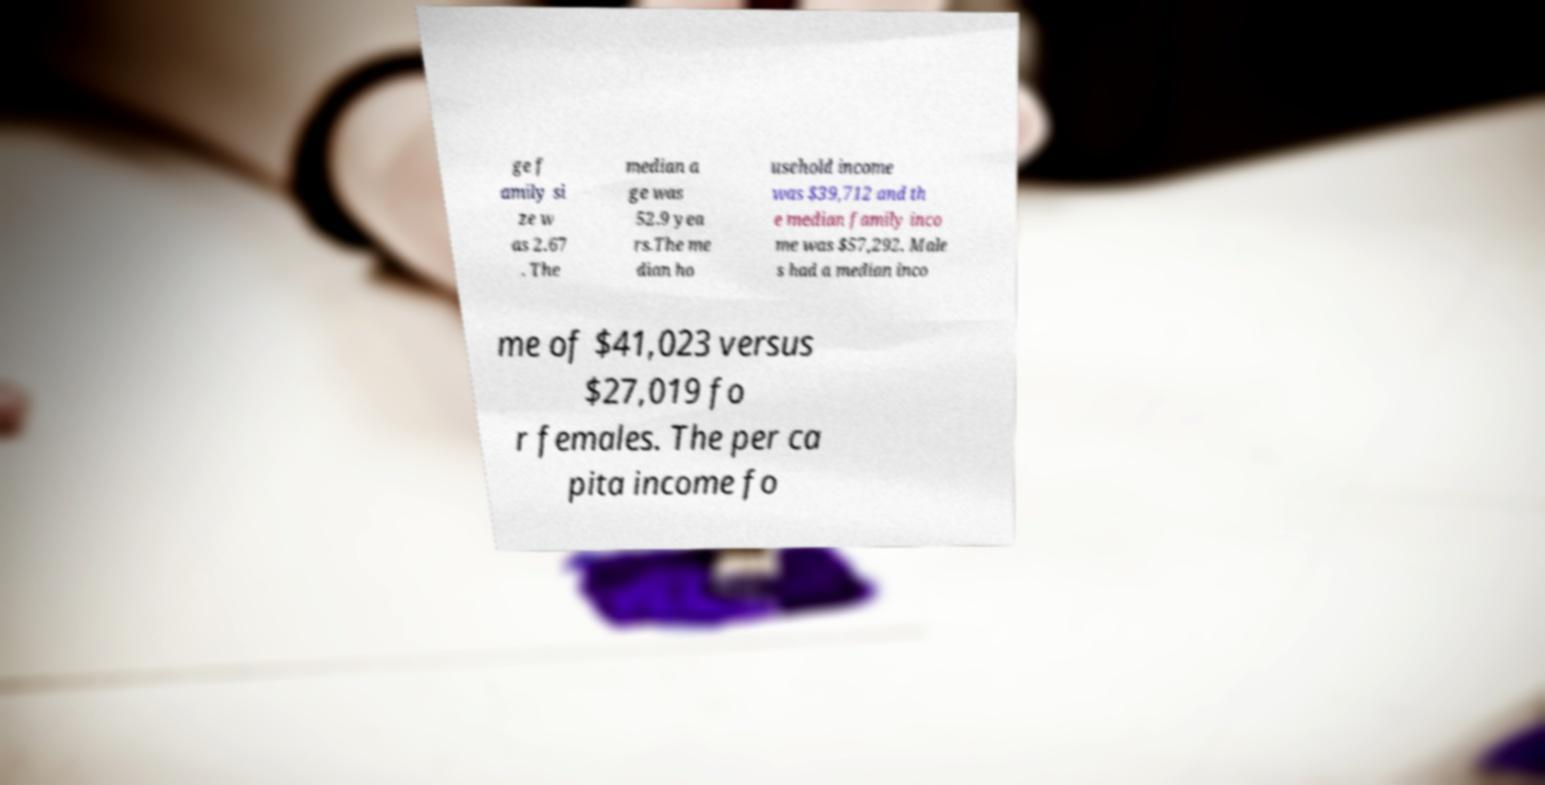Can you read and provide the text displayed in the image?This photo seems to have some interesting text. Can you extract and type it out for me? ge f amily si ze w as 2.67 . The median a ge was 52.9 yea rs.The me dian ho usehold income was $39,712 and th e median family inco me was $57,292. Male s had a median inco me of $41,023 versus $27,019 fo r females. The per ca pita income fo 